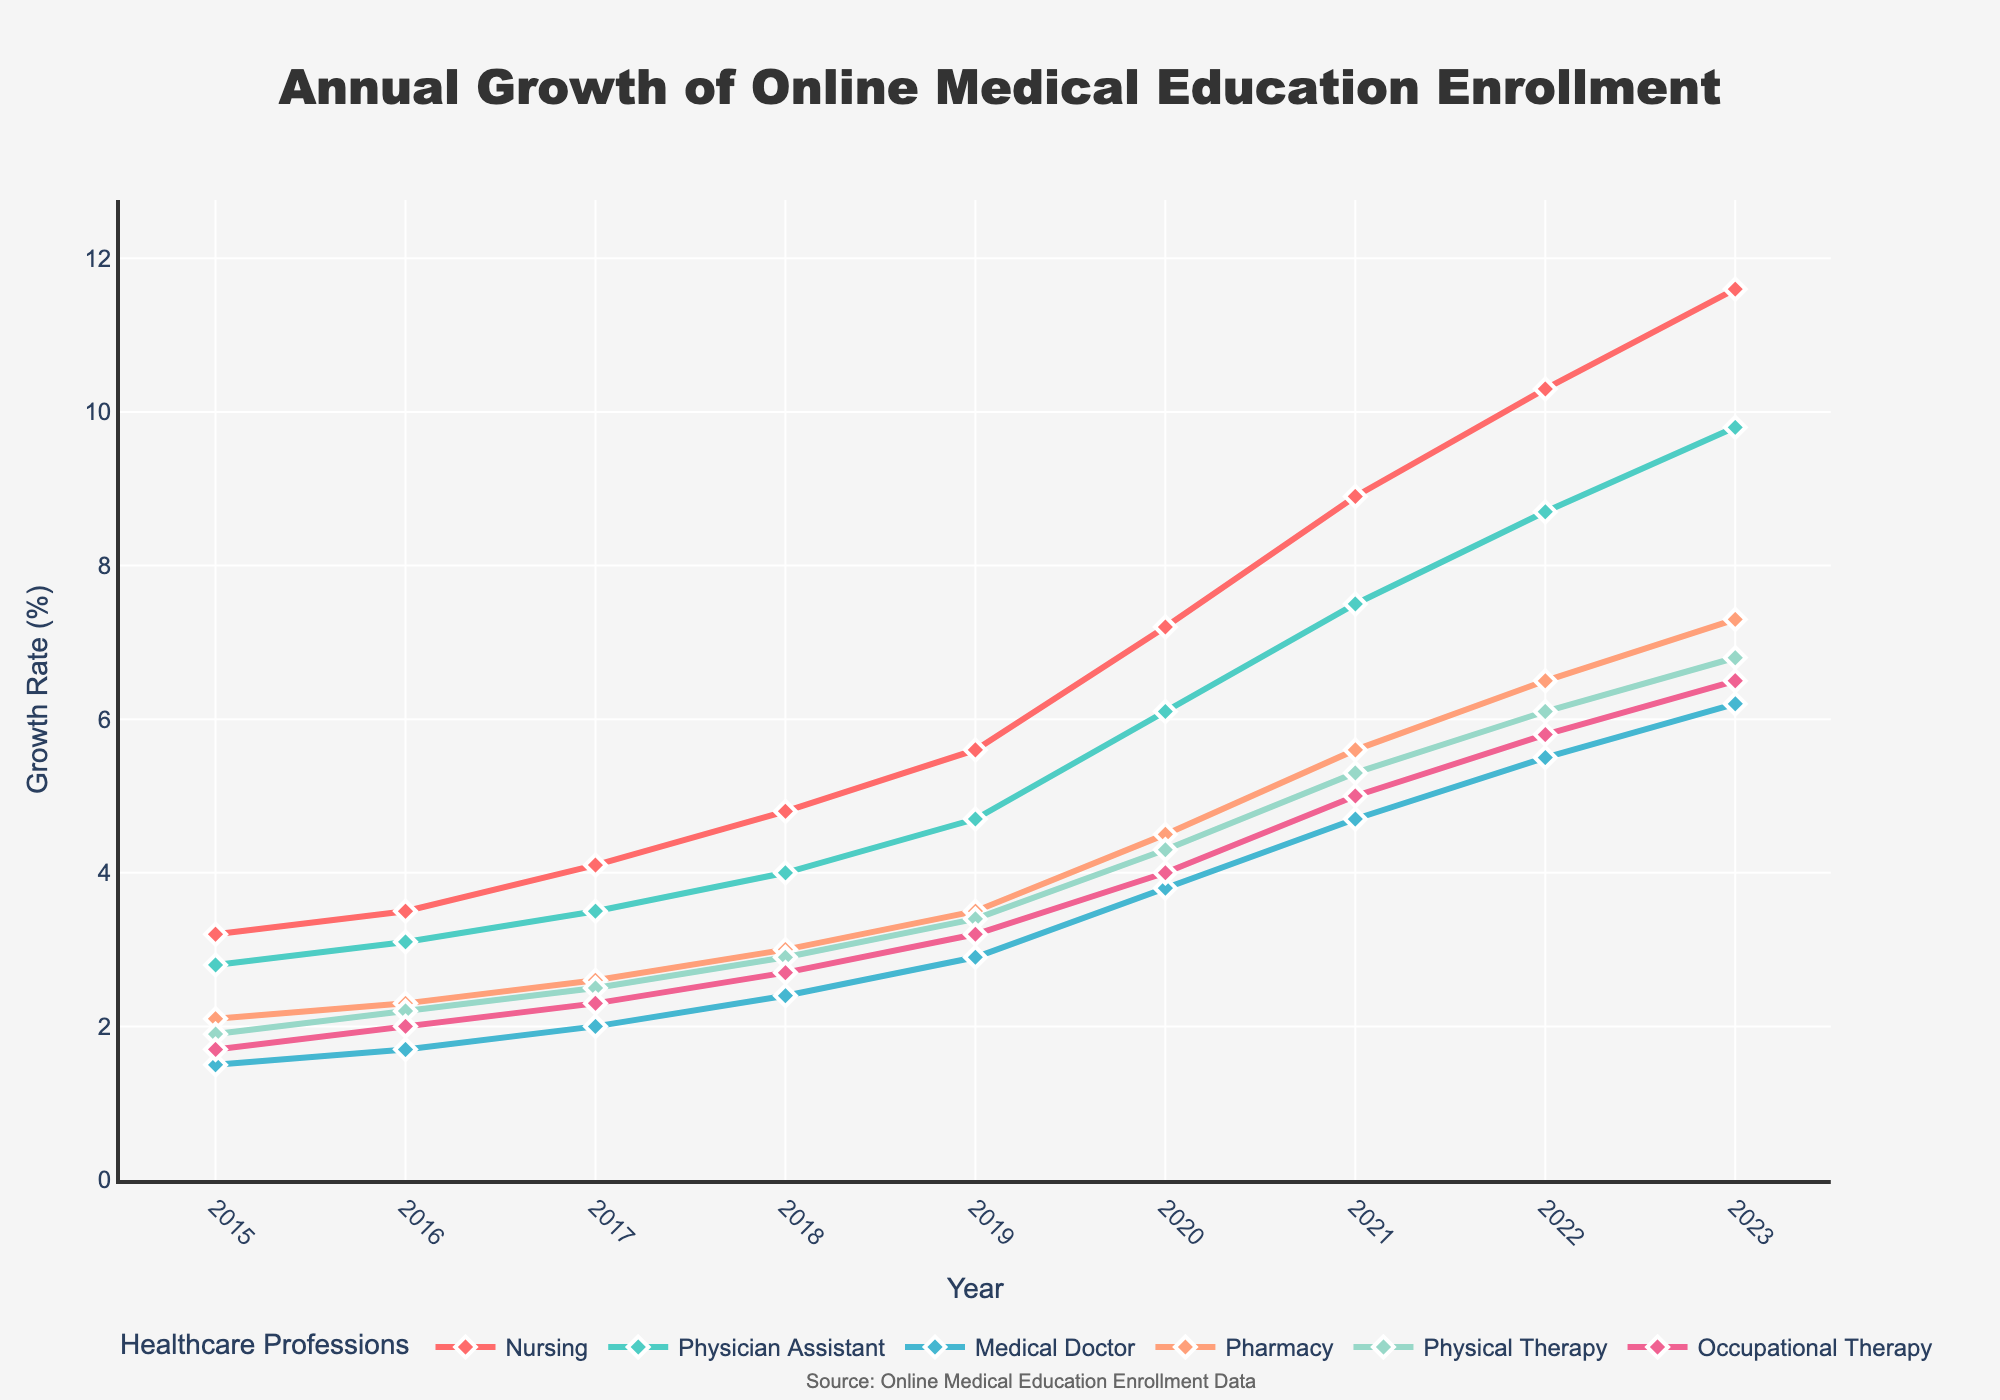What is the difference in enrollment growth between "Nursing" and "Medical Doctor" in 2023? "Nursing" had an enrollment growth of 11.6% in 2023, while "Medical Doctor" had 6.2%. The difference is computed as 11.6 - 6.2.
Answer: 5.4% Which healthcare profession had the highest enrollment growth in 2020? Visual inspection of the chart at the year 2020 indicates that "Nursing" has the highest enrollment growth compared to the other professions.
Answer: Nursing How did the growth rate for "Physical Therapy" change from 2016 to 2018? "Physical Therapy" had a growth rate of 2.2% in 2016 and 2.9% in 2018. The change is calculated as 2.9 - 2.2.
Answer: 0.7% What is the average growth rate for "Pharmacy" from 2017 to 2019? "Pharmacy" had growth rates of 2.6%, 3.0%, and 3.5% in 2017, 2018, and 2019, respectively. The average is calculated as (2.6 + 3.0 + 3.5) / 3.
Answer: 3.03% Which profession showed a steeper increase in growth rate from 2019 to 2020, "Physician Assistant" or "Medical Doctor"? "Physician Assistant" grew from 4.7% in 2019 to 6.1% in 2020 (increase of 1.4%), while "Medical Doctor" grew from 2.9% to 3.8% (increase of 0.9%). "Physician Assistant" had a steeper increase.
Answer: Physician Assistant What is the total growth for "Occupational Therapy" over the 9-year span from 2015 to 2023? "Occupational Therapy" enrollment grew from 1.7% in 2015 to 6.5% in 2023. The total growth is calculated as 6.5 - 1.7.
Answer: 4.8% Between which two consecutive years did "Nursing" experience the highest growth rate increase? By examining the slopes of the lines, "Nursing" experienced the highest increase between 2019 (5.6%) and 2020 (7.2%), which is calculated as 7.2 - 5.6.
Answer: 2019 and 2020 How many healthcare professions had a growth rate greater than 5% in 2023? Visual inspection of the figures at the year 2023 indicates that "Nursing," "Physician Assistant," "Medical Doctor," "Pharmacy," "Physical Therapy," and "Occupational Therapy" all had growth rates greater than 5%.
Answer: 6 